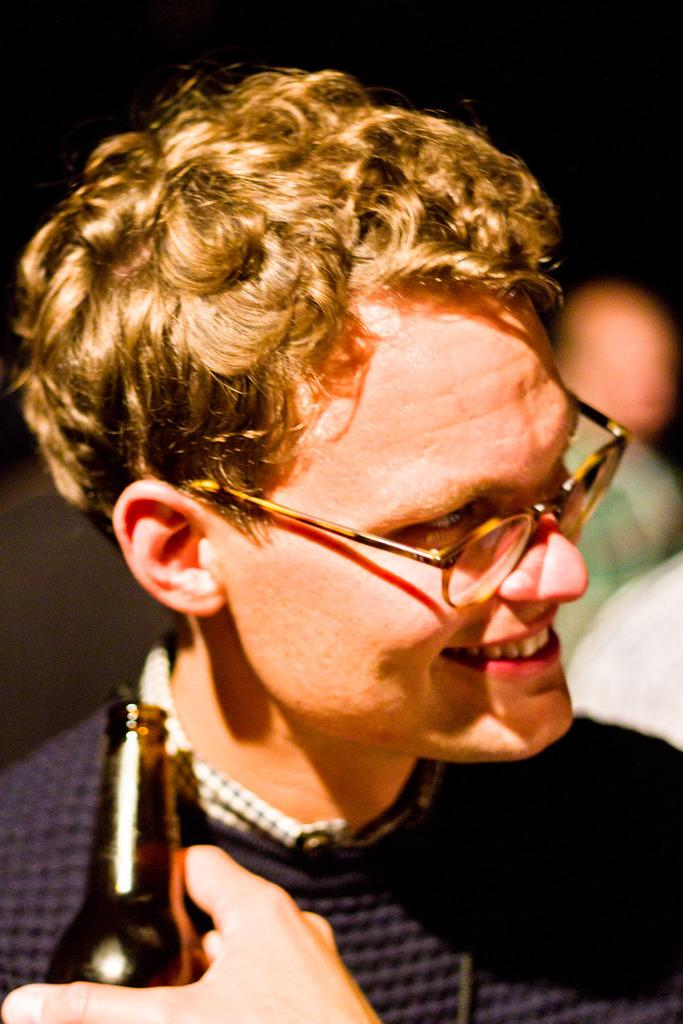What is the appearance of the man in the image? The man in the image is wearing glasses and a blue shirt. Can you describe the person in front of the man? The person in front of the man is holding a bottle. What is the condition of the background in the image? The background of the image is blurred. Is the man in the image sinking into quicksand? There is no quicksand present in the image, so the man is not sinking into it. What joke is the man telling in the image? There is no indication of a joke being told in the image; the man is simply standing there with a person in front of him holding a bottle. 